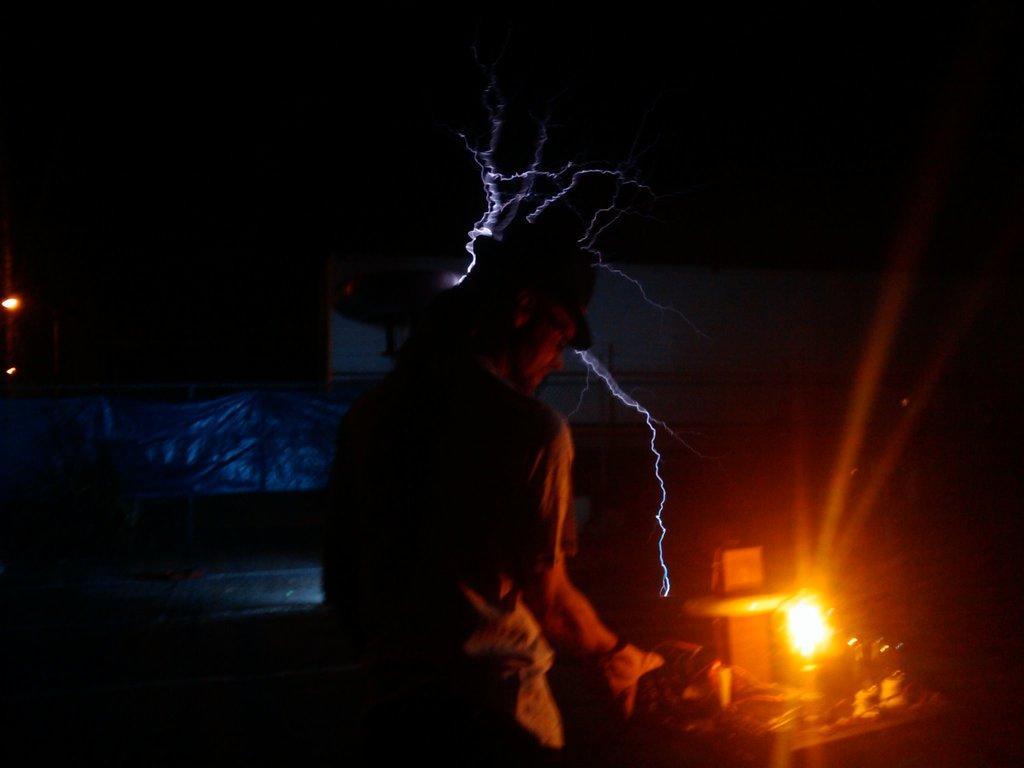How would you summarize this image in a sentence or two? In the center of the image we can see a man. On the right there is a lamp. In the background we can see a tent and there is a board. On the left there are lights. 